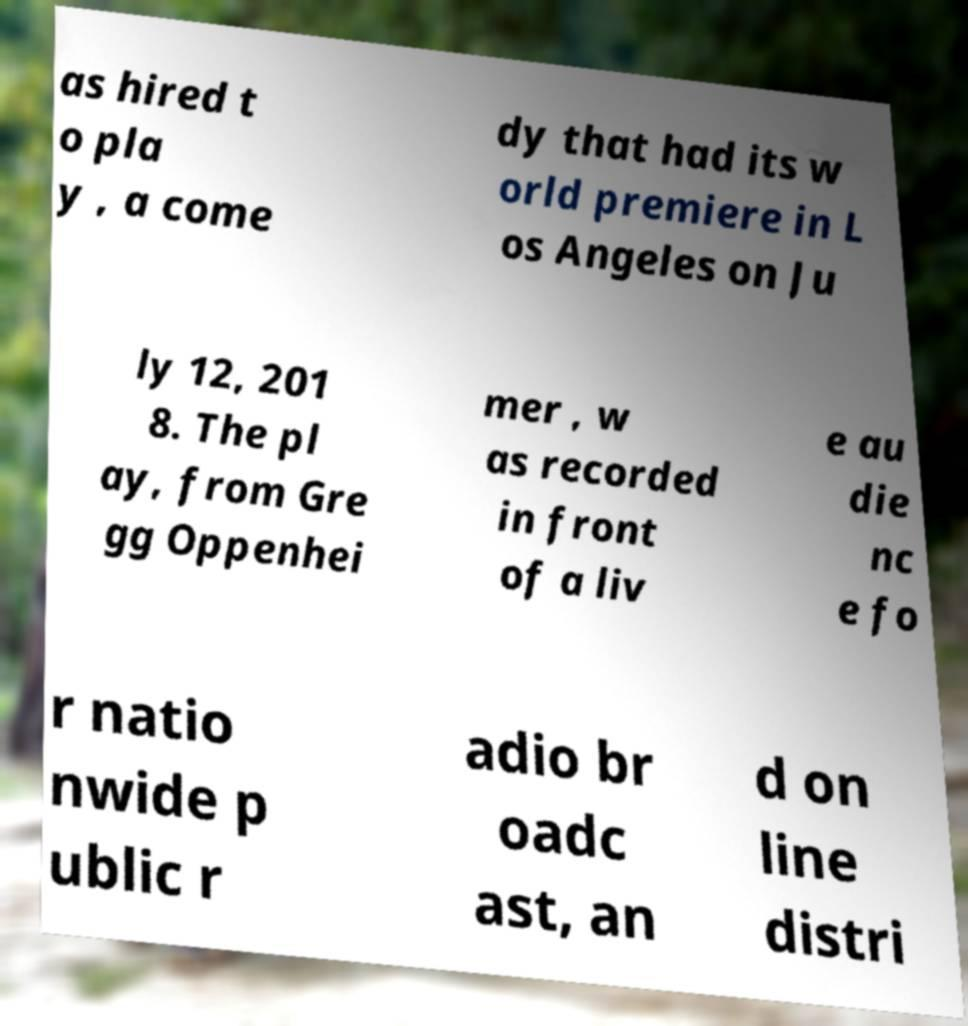There's text embedded in this image that I need extracted. Can you transcribe it verbatim? as hired t o pla y , a come dy that had its w orld premiere in L os Angeles on Ju ly 12, 201 8. The pl ay, from Gre gg Oppenhei mer , w as recorded in front of a liv e au die nc e fo r natio nwide p ublic r adio br oadc ast, an d on line distri 